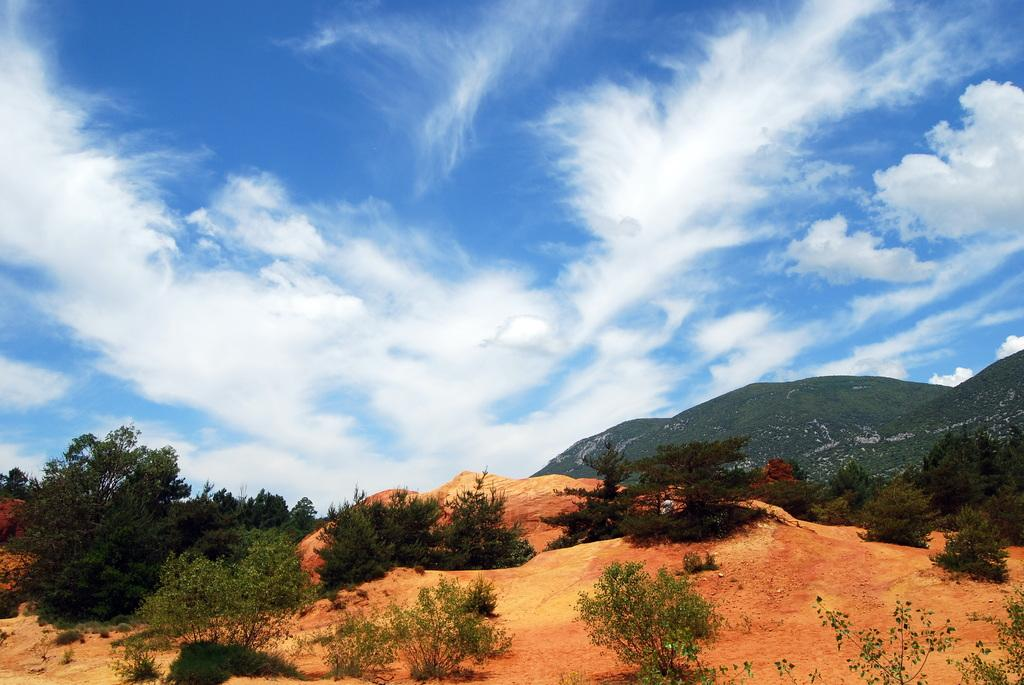What type of natural features can be seen in the image? There are trees and mountains in the image. What part of the natural environment is visible in the image? The sky is visible in the image. What type of cap is visible on the roof of the house in the image? There is no house or roof present in the image; it features trees, mountains, and the sky. 